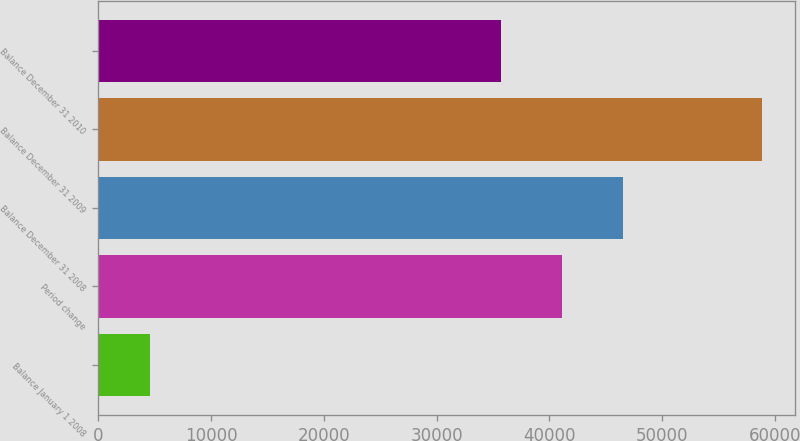Convert chart to OTSL. <chart><loc_0><loc_0><loc_500><loc_500><bar_chart><fcel>Balance January 1 2008<fcel>Period change<fcel>Balance December 31 2008<fcel>Balance December 31 2009<fcel>Balance December 31 2010<nl><fcel>4553<fcel>41141.2<fcel>46572.4<fcel>58865<fcel>35710<nl></chart> 